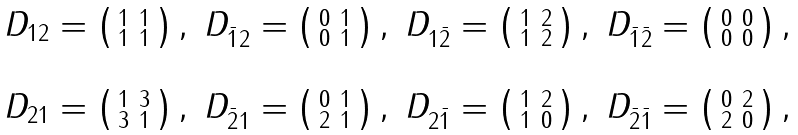<formula> <loc_0><loc_0><loc_500><loc_500>\begin{matrix} D _ { 1 2 } = \left ( \begin{smallmatrix} 1 & 1 \\ 1 & 1 \end{smallmatrix} \right ) , & D _ { \bar { 1 } 2 } = \left ( \begin{smallmatrix} 0 & 1 \\ 0 & 1 \end{smallmatrix} \right ) , & D _ { 1 \bar { 2 } } = \left ( \begin{smallmatrix} 1 & 2 \\ 1 & 2 \end{smallmatrix} \right ) , & D _ { \bar { 1 } \bar { 2 } } = \left ( \begin{smallmatrix} 0 & 0 \\ 0 & 0 \end{smallmatrix} \right ) , \\ \\ D _ { 2 1 } = \left ( \begin{smallmatrix} 1 & 3 \\ 3 & 1 \end{smallmatrix} \right ) , & D _ { \bar { 2 } 1 } = \left ( \begin{smallmatrix} 0 & 1 \\ 2 & 1 \end{smallmatrix} \right ) , & D _ { 2 \bar { 1 } } = \left ( \begin{smallmatrix} 1 & 2 \\ 1 & 0 \end{smallmatrix} \right ) , & D _ { \bar { 2 } \bar { 1 } } = \left ( \begin{smallmatrix} 0 & 2 \\ 2 & 0 \end{smallmatrix} \right ) , \end{matrix}</formula> 